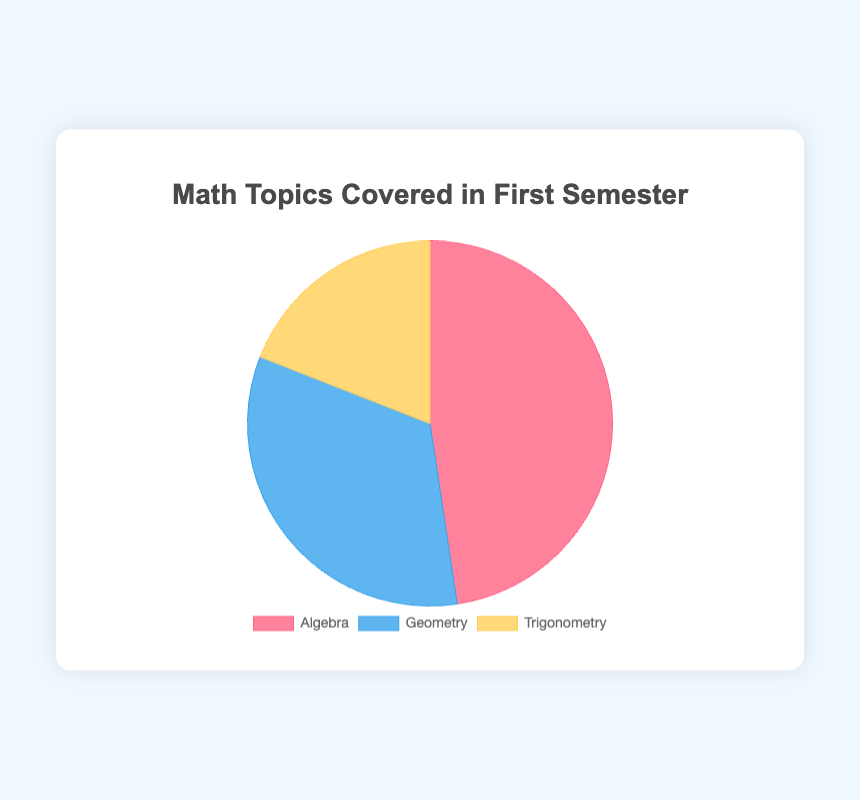What percentage of the first semester math topics is dedicated to Algebra? The figure shows the percentage each topic takes. Algebra covers 50% of the total math topics. This is the largest section in the pie chart, represented in red color.
Answer: 50% Which math topic covers the least percentage of the first semester's curriculum? By visual inspection of the pie chart, Trigonometry has the smallest section, indicated by the yellow color, which covers 20% of the curriculum.
Answer: Trigonometry How much more of the semester is spent on Geometry compared to Trigonometry? Geometry covers 35% of the curriculum, and Trigonometry covers 20%. By subtracting the percentage for Trigonometry from Geometry (35% - 20%), we find that 15% more of the semester is spent on Geometry.
Answer: 15% If the focus were to be equally distributed among the three topics, what would be the new percentage for each? To find the equal distribution, divide 100% by 3, which is approximately 33.33% for each topic.
Answer: 33.33% What is the combined percentage of time spent on Linear Equations, Quadratic Equations, and Polynomials in the Algebra category? Adding the contributions: Linear Equations (20%) + Quadratic Equations (15%) + Polynomials (10%) results in 45%.
Answer: 45% Compare the sum of percentages of the two smallest sections in the chart. What is their combined percentage and how does it relate to the largest section? The smallest sections are Trigonometry (20%) and Geometry (35%). Summing them results in 55%. Compared to Algebra, which is 50%, the combined percentage of the two smallest sections (55%) is 5% more than the largest section.
Answer: The combined percentage is 55% and it is 5% more than Algebra What fraction of the first semester is spent on topics other than Trigonometry? Since Trigonometry takes 20%, the rest of the semester dedicated to Algebra and Geometry is 100% - 20% = 80%.
Answer: 80% Given that Quadratic Equations account for 15% of the semester, how does it compare to the overall contribution of Geometry? Quadratic Equations contribute 15%, while Geometry contributes 35%. Therefore, Geometry is greater by 35% - 15% = 20%.
Answer: 20% Are there any categories in the pie chart that have the same percentage of coverage? Visual inspection shows that none of the sections have the same percentage coverages (50%, 35%, and 20%). Every section has a unique percentage.
Answer: No 